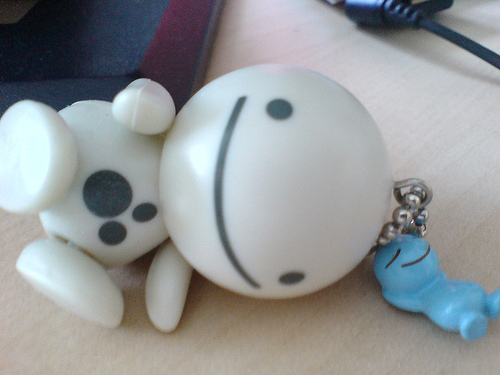<image>
Is the toy under the table? No. The toy is not positioned under the table. The vertical relationship between these objects is different. Is the cord behind the usb? No. The cord is not behind the usb. From this viewpoint, the cord appears to be positioned elsewhere in the scene. 